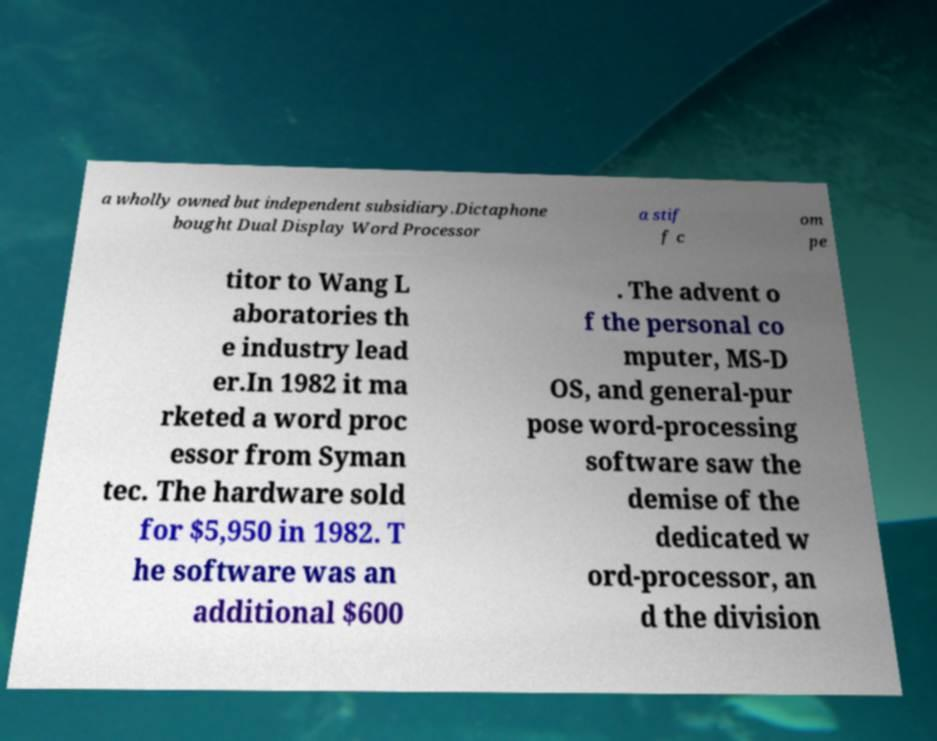What messages or text are displayed in this image? I need them in a readable, typed format. a wholly owned but independent subsidiary.Dictaphone bought Dual Display Word Processor a stif f c om pe titor to Wang L aboratories th e industry lead er.In 1982 it ma rketed a word proc essor from Syman tec. The hardware sold for $5,950 in 1982. T he software was an additional $600 . The advent o f the personal co mputer, MS-D OS, and general-pur pose word-processing software saw the demise of the dedicated w ord-processor, an d the division 